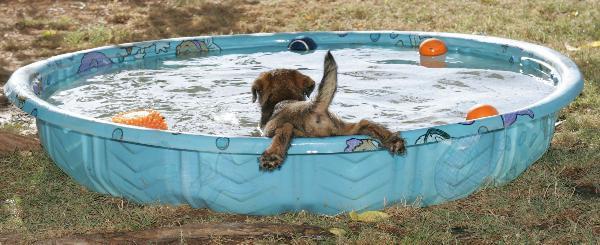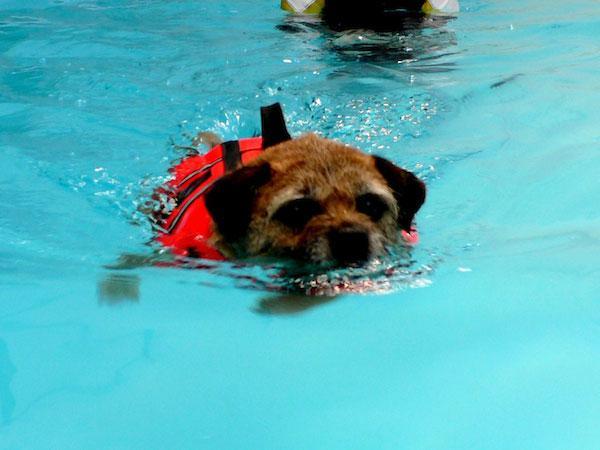The first image is the image on the left, the second image is the image on the right. Evaluate the accuracy of this statement regarding the images: "Only one of the images shows a dog in a scene with water, and that image shows the bottom ground underneath the water.". Is it true? Answer yes or no. No. The first image is the image on the left, the second image is the image on the right. Examine the images to the left and right. Is the description "In the image on the left, there isn't any body of water." accurate? Answer yes or no. No. 